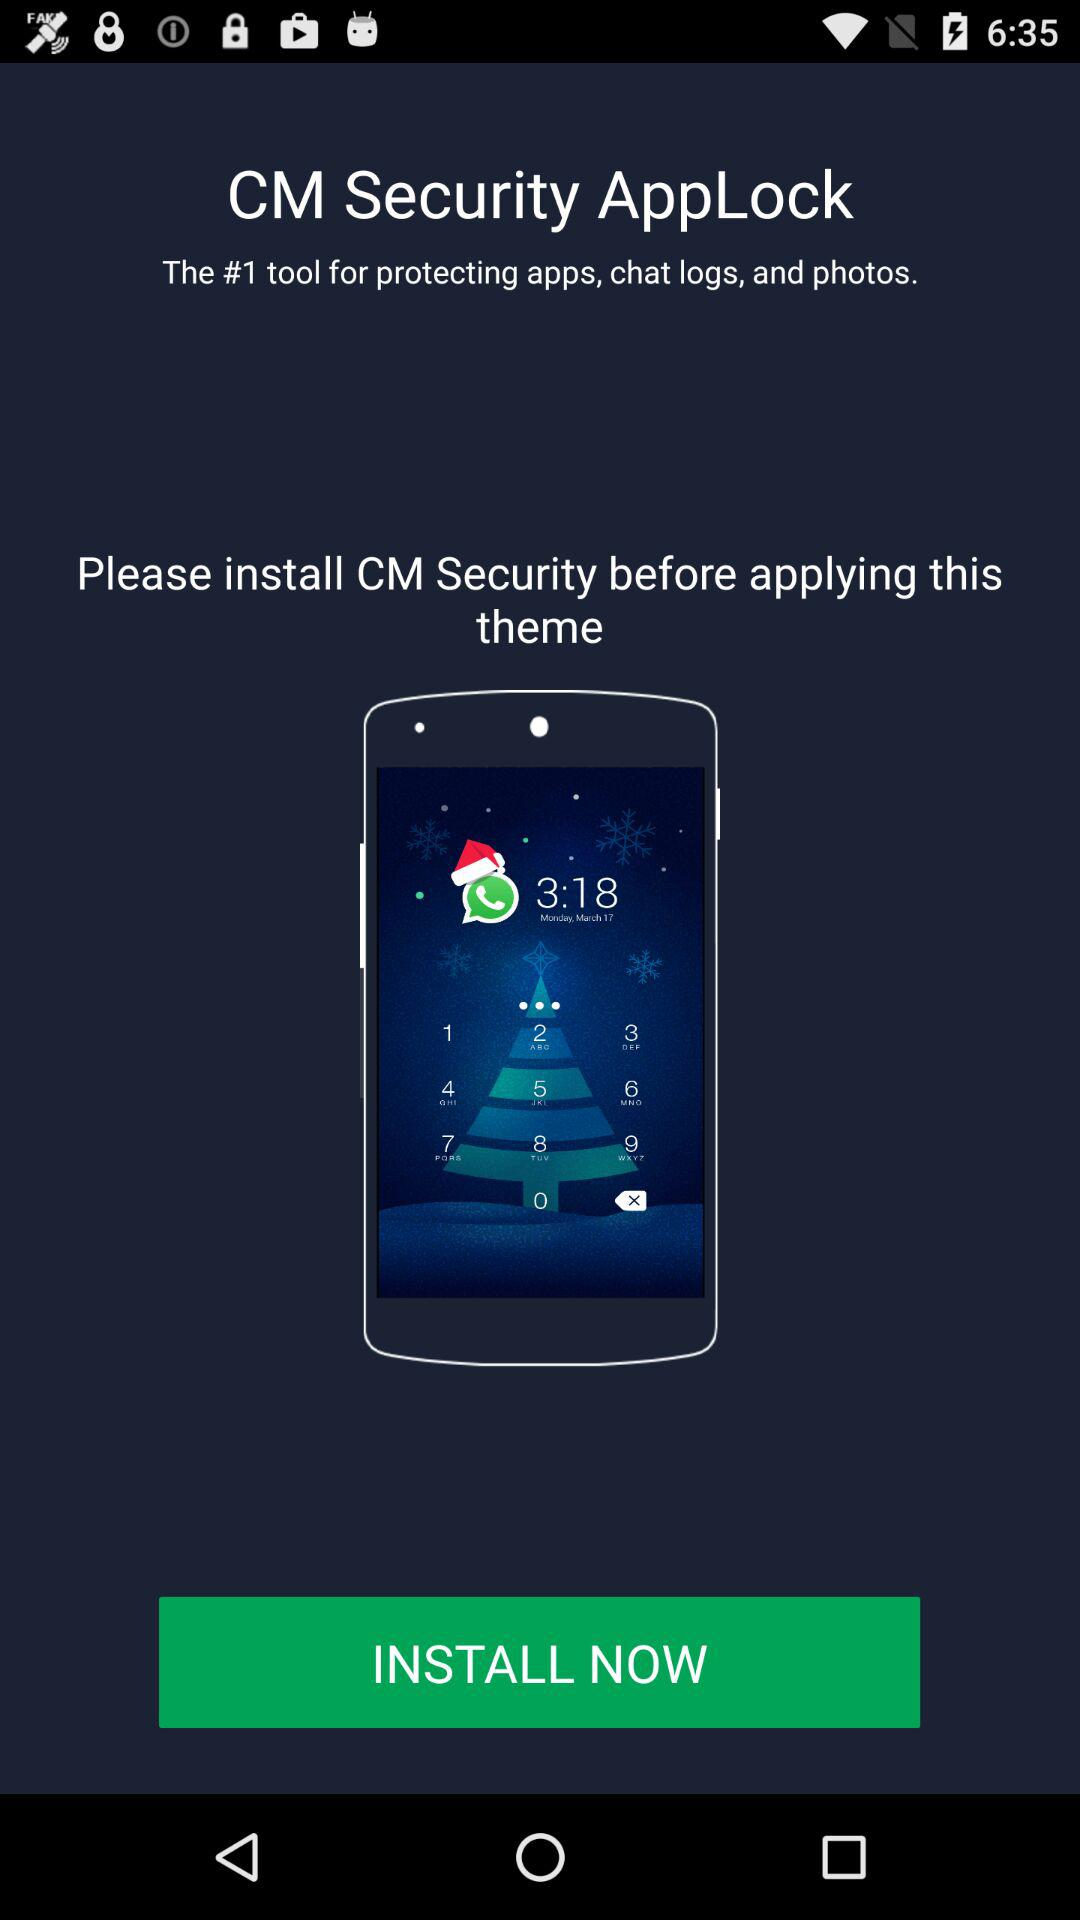What is the name of the application? The name of the application is "CM Security". 